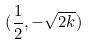<formula> <loc_0><loc_0><loc_500><loc_500>( \frac { 1 } { 2 } , - \sqrt { 2 k } )</formula> 